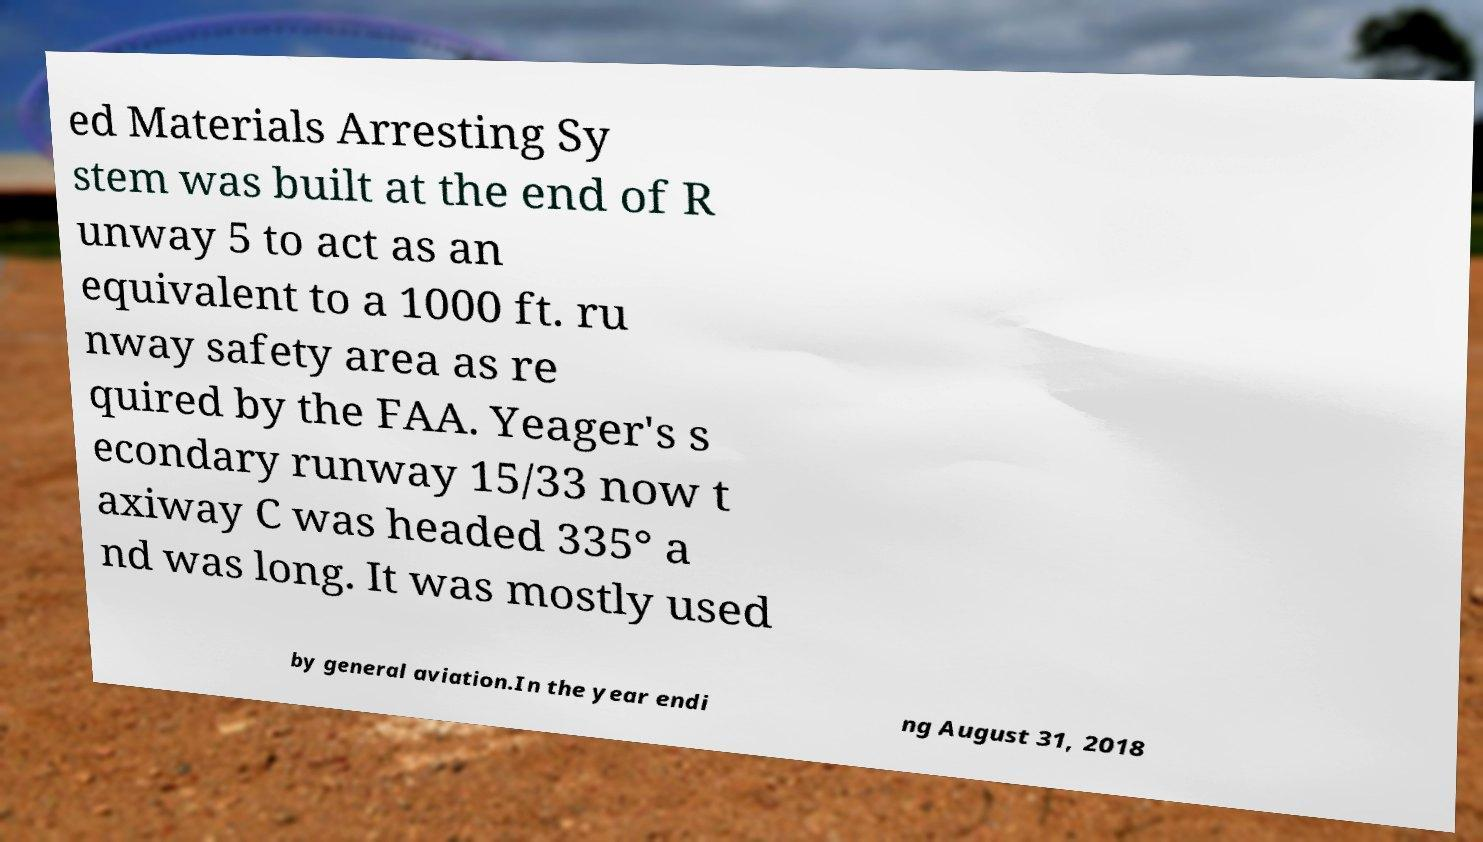I need the written content from this picture converted into text. Can you do that? ed Materials Arresting Sy stem was built at the end of R unway 5 to act as an equivalent to a 1000 ft. ru nway safety area as re quired by the FAA. Yeager's s econdary runway 15/33 now t axiway C was headed 335° a nd was long. It was mostly used by general aviation.In the year endi ng August 31, 2018 